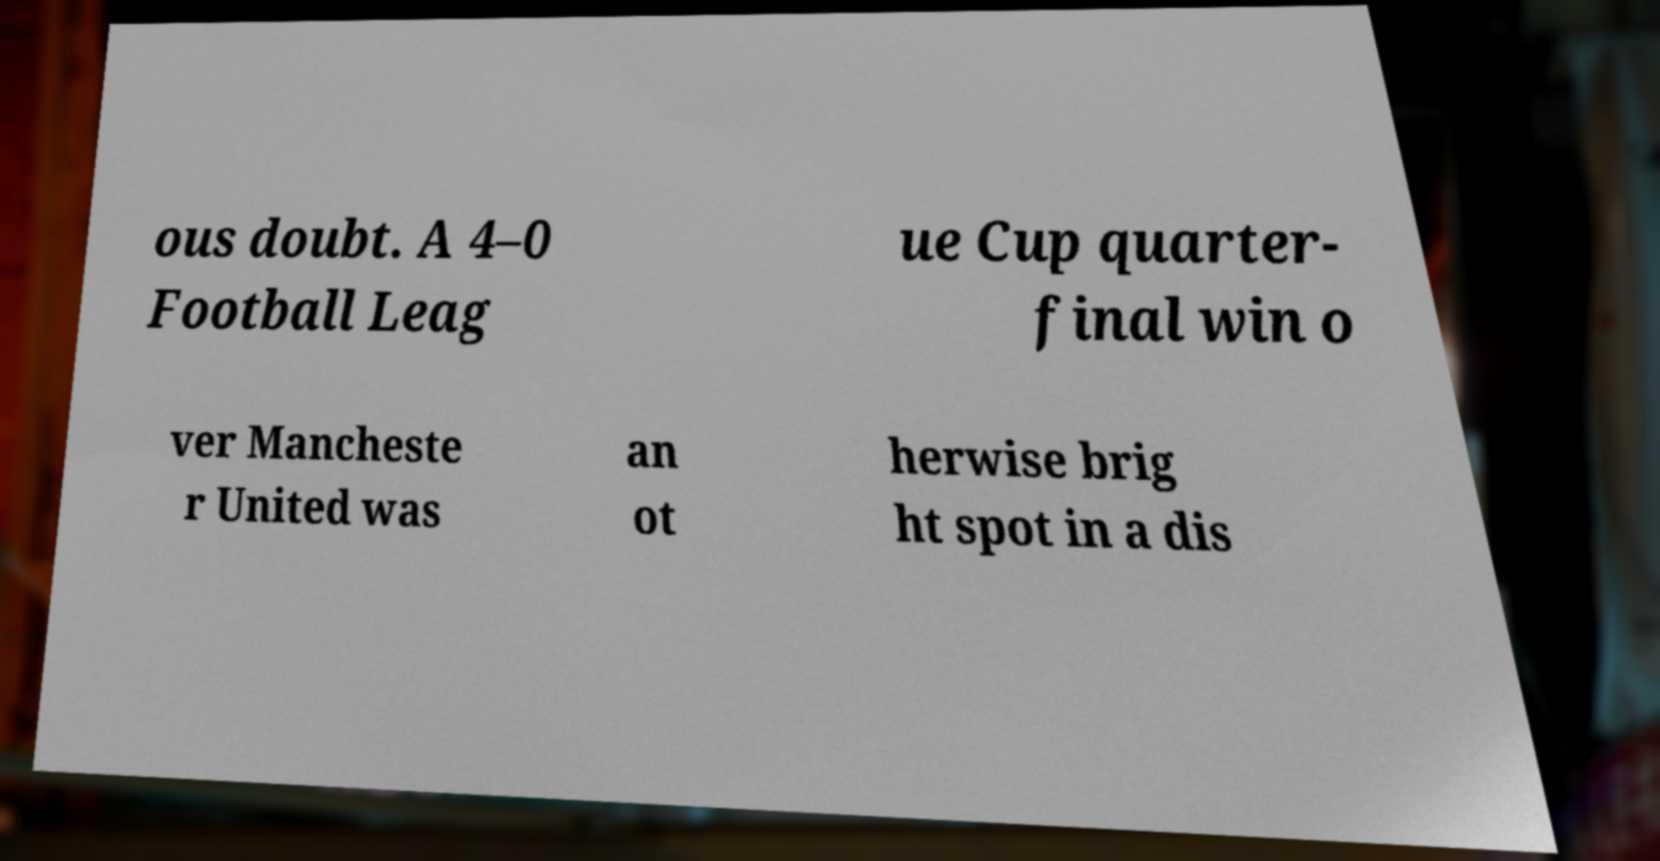Please identify and transcribe the text found in this image. ous doubt. A 4–0 Football Leag ue Cup quarter- final win o ver Mancheste r United was an ot herwise brig ht spot in a dis 